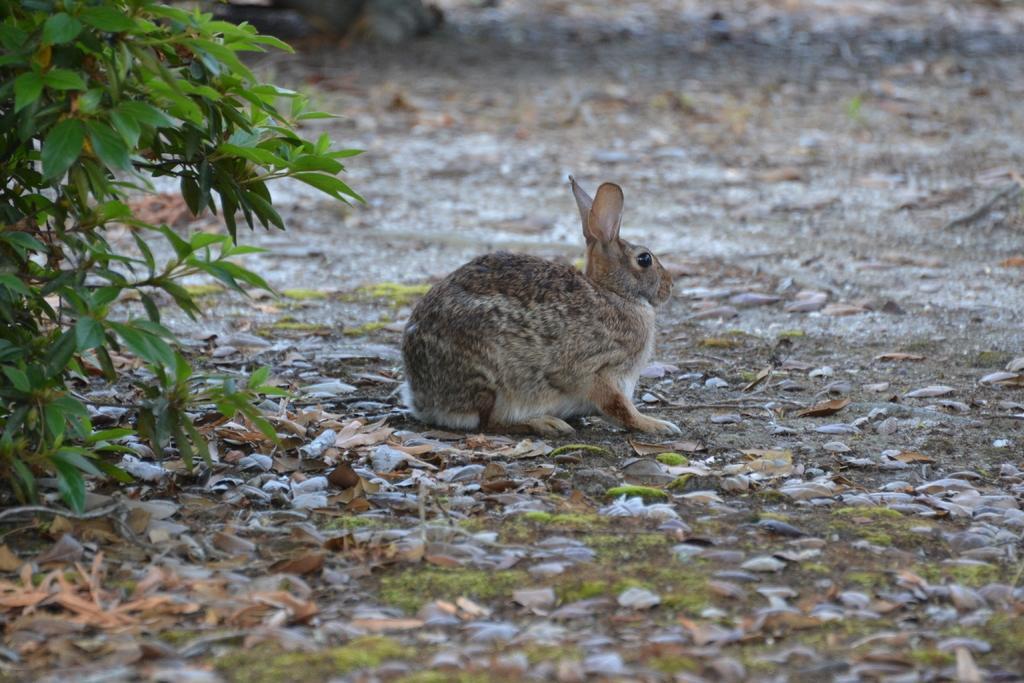Can you describe this image briefly? In the center of image we can see a rabbit. On the left there is a plant. At the bottom there are leaves. 